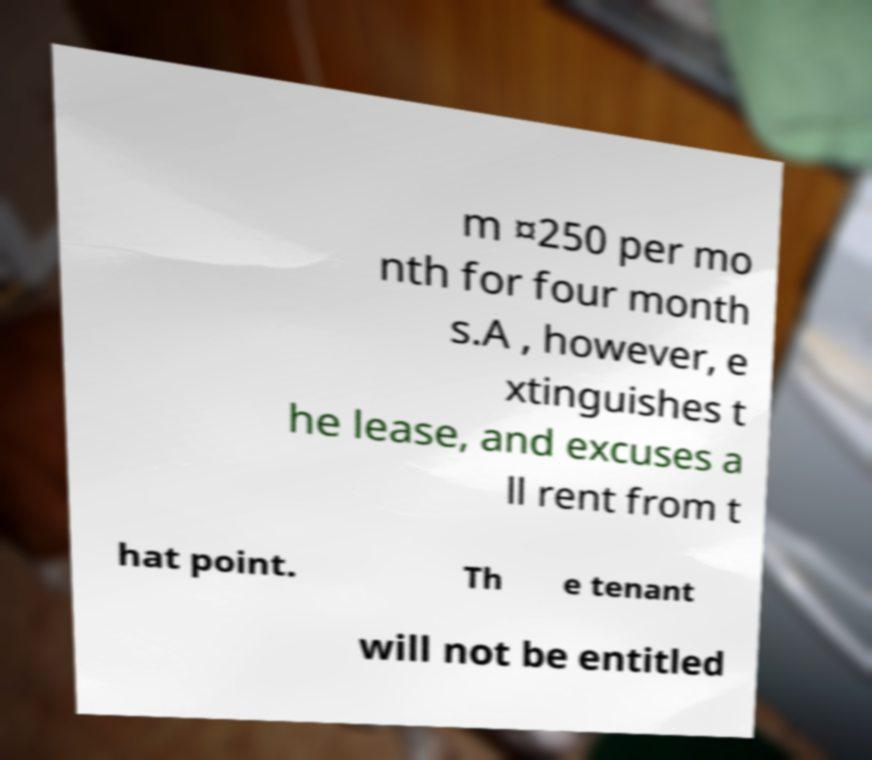For documentation purposes, I need the text within this image transcribed. Could you provide that? m ¤250 per mo nth for four month s.A , however, e xtinguishes t he lease, and excuses a ll rent from t hat point. Th e tenant will not be entitled 